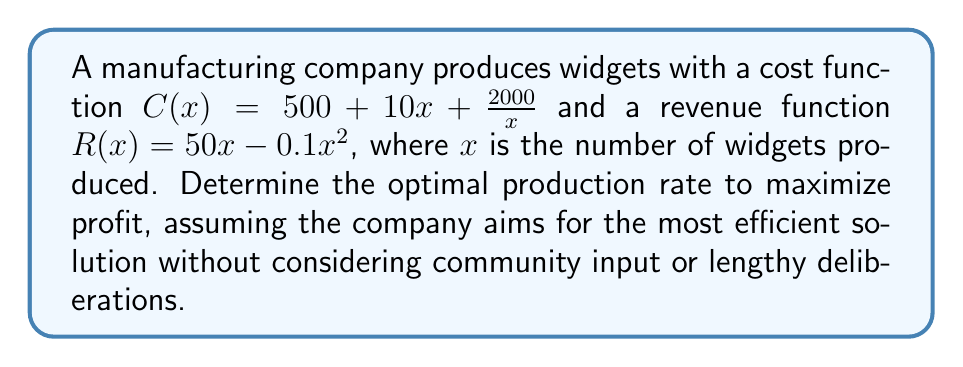Can you solve this math problem? 1) The profit function $P(x)$ is the difference between revenue and cost:
   $$P(x) = R(x) - C(x) = (50x - 0.1x^2) - (500 + 10x + \frac{2000}{x})$$

2) Simplify the profit function:
   $$P(x) = -0.1x^2 + 40x - 500 - \frac{2000}{x}$$

3) To find the maximum profit, we need to find where the derivative of $P(x)$ equals zero:
   $$P'(x) = -0.2x + 40 + \frac{2000}{x^2}$$

4) Set $P'(x) = 0$ and solve for x:
   $$-0.2x + 40 + \frac{2000}{x^2} = 0$$

5) Multiply both sides by $x^2$:
   $$-0.2x^3 + 40x^2 + 2000 = 0$$

6) This is a cubic equation. For efficiency, we can solve it using a graphing calculator or computer algebra system. The solution relevant to our problem (positive real root) is approximately:
   $$x \approx 141.4$$

7) To confirm this is a maximum, we can check that $P''(x) < 0$ at this point:
   $$P''(x) = -0.2 - \frac{4000}{x^3}$$
   At $x = 141.4$, $P''(x) < 0$, confirming a maximum.
Answer: 141.4 widgets 